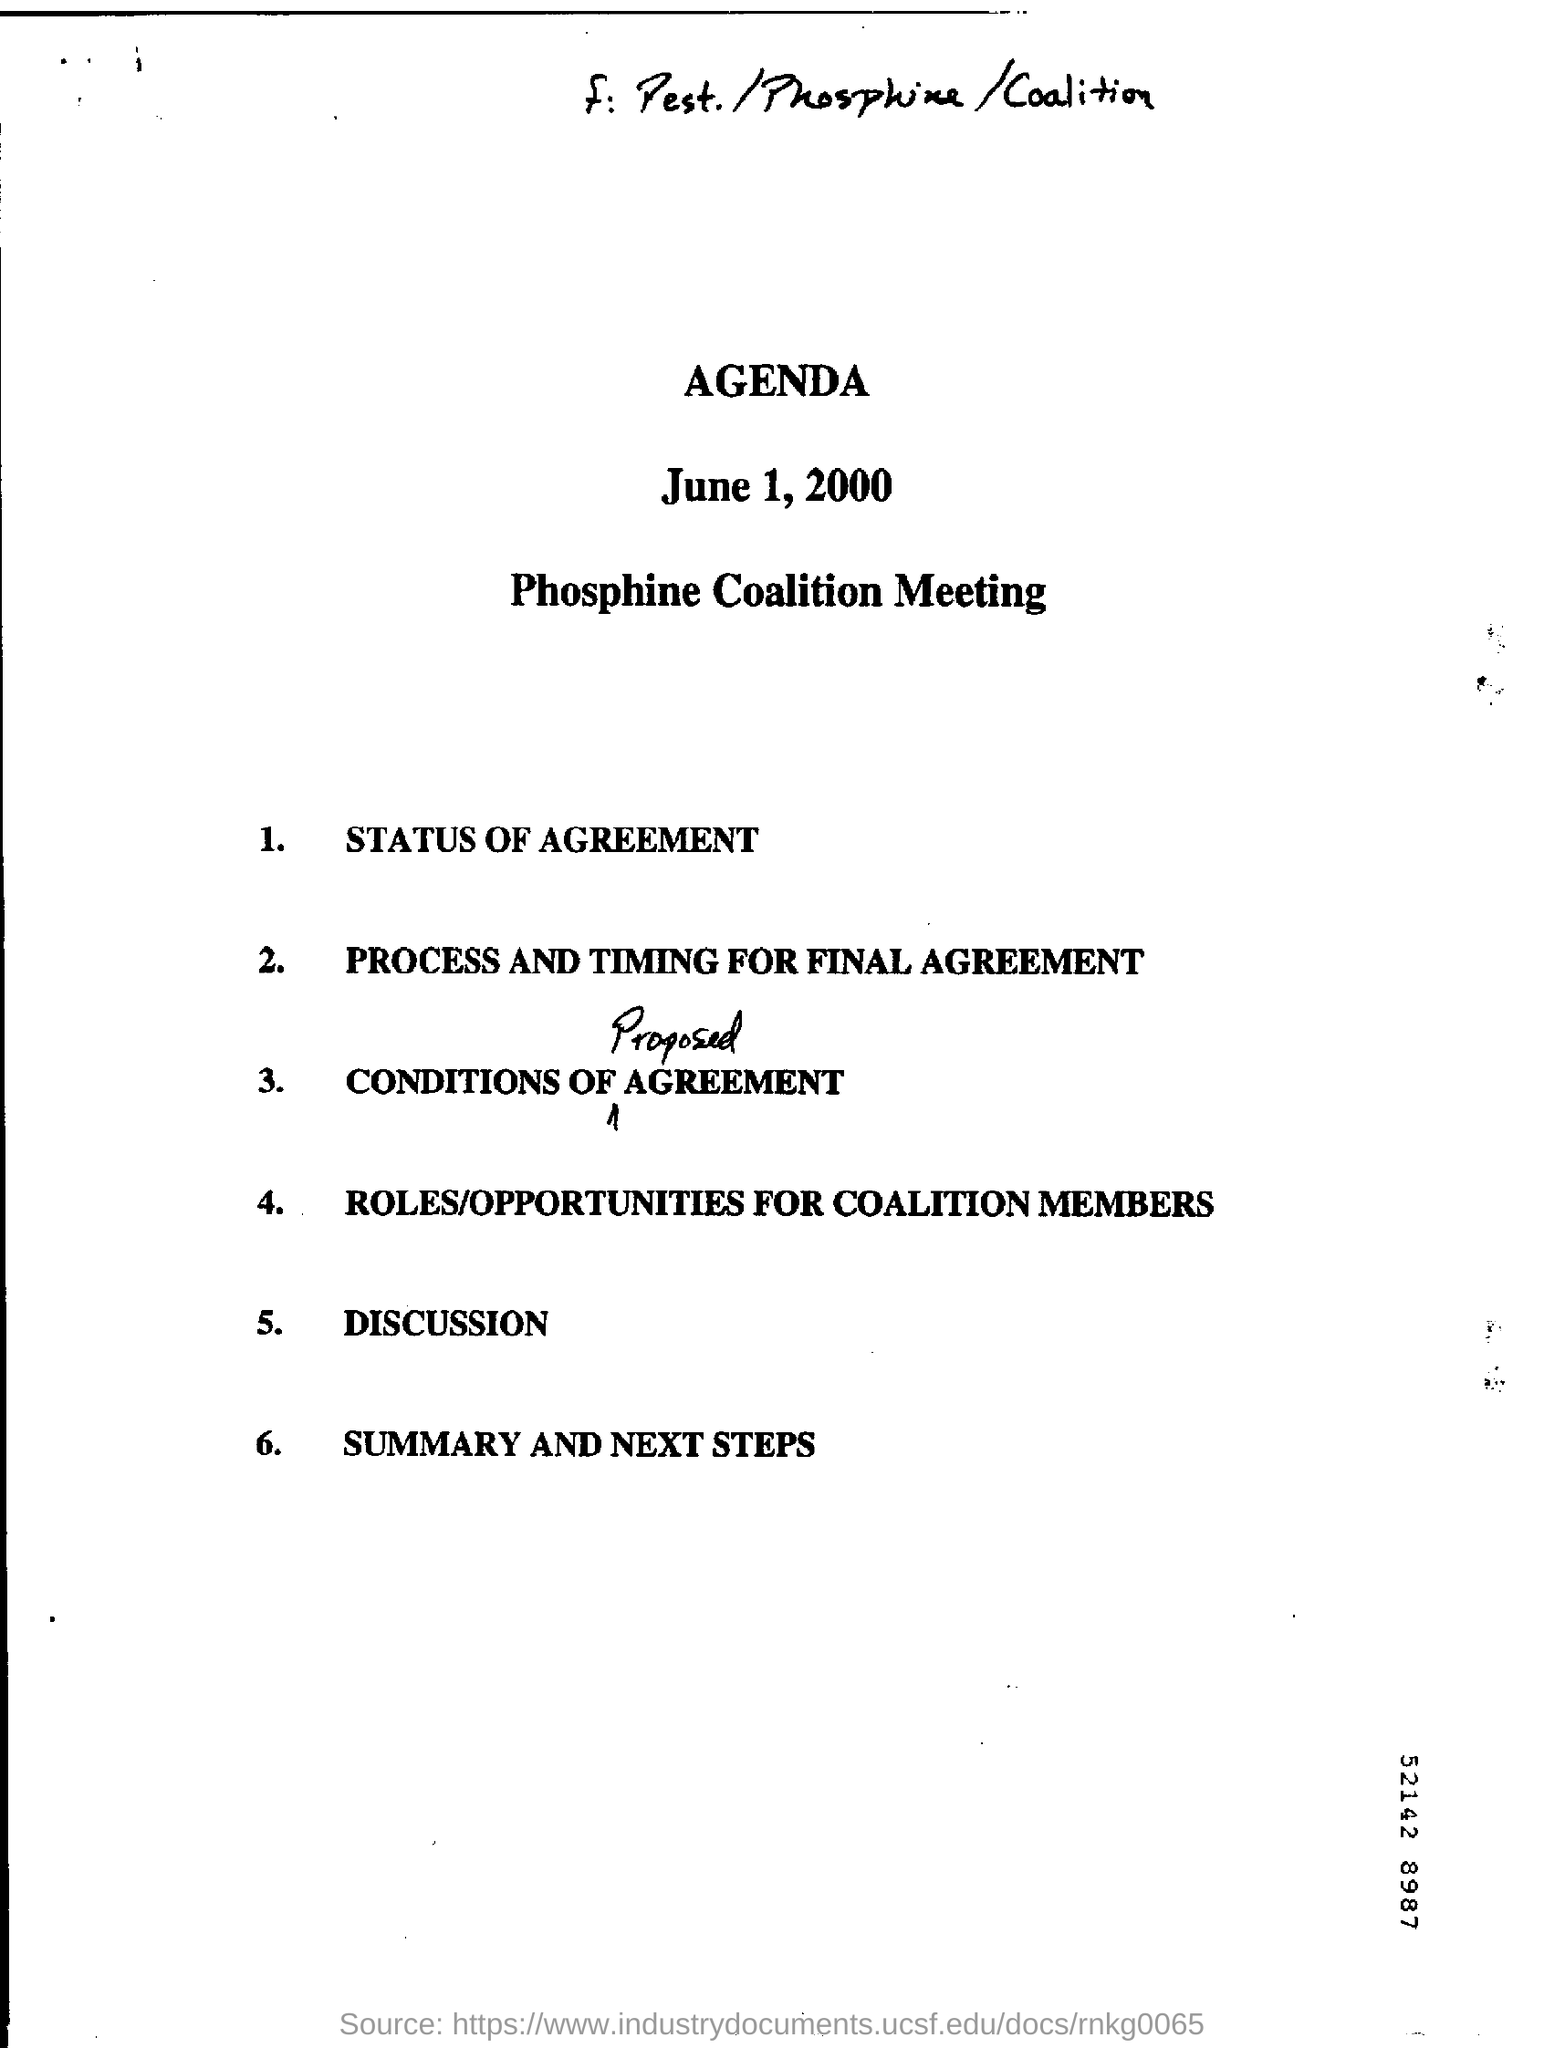Point out several critical features in this image. The fifth point of the agenda is discussion. The handwritten word in the third point is "PROPOSED. The heading 'AGENDA' declares the purpose of the document or meeting, indicating what topics will be discussed and addressed. 